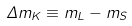Convert formula to latex. <formula><loc_0><loc_0><loc_500><loc_500>\Delta m _ { K } \equiv m _ { L } - m _ { S }</formula> 